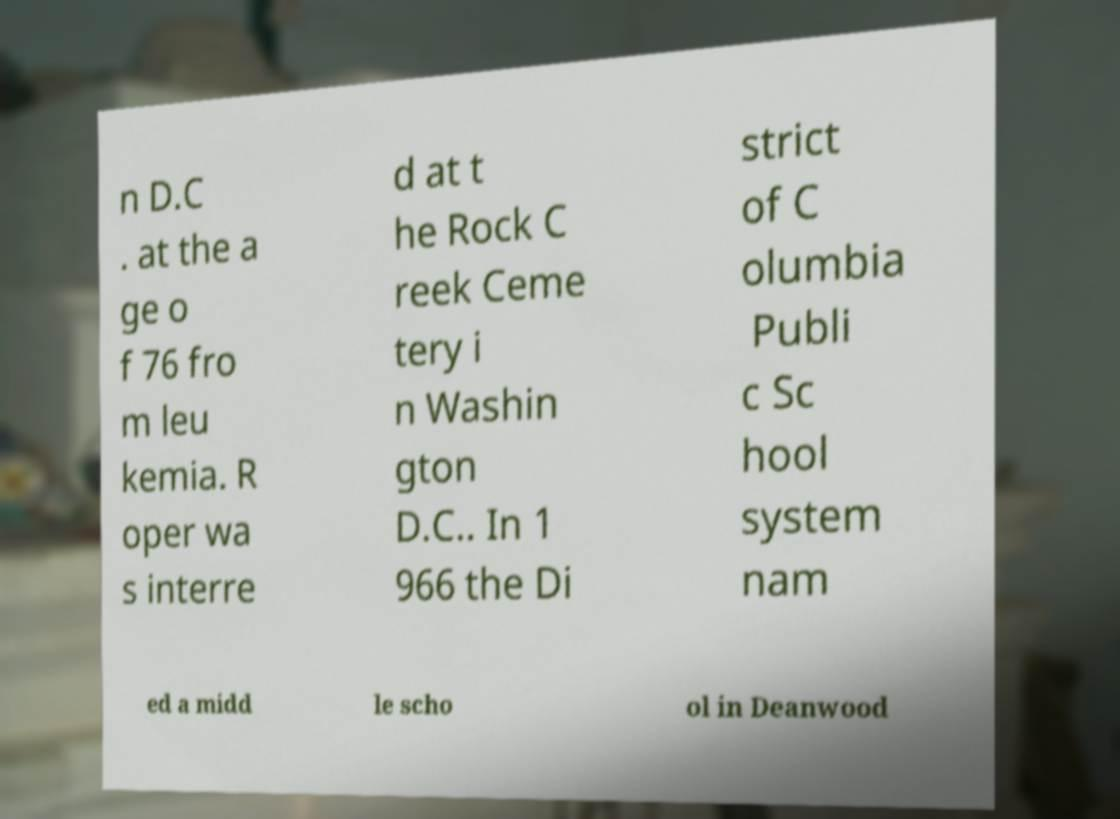There's text embedded in this image that I need extracted. Can you transcribe it verbatim? n D.C . at the a ge o f 76 fro m leu kemia. R oper wa s interre d at t he Rock C reek Ceme tery i n Washin gton D.C.. In 1 966 the Di strict of C olumbia Publi c Sc hool system nam ed a midd le scho ol in Deanwood 